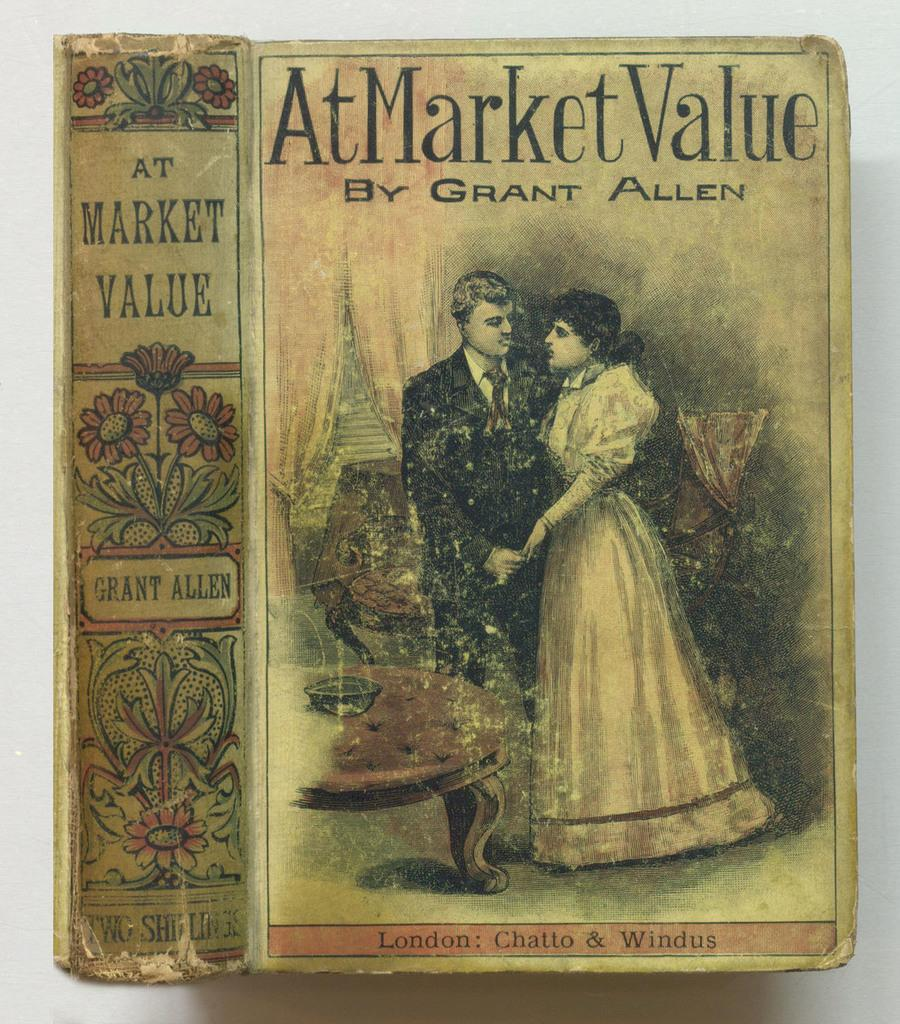<image>
Present a compact description of the photo's key features. An antique book titled At Market Value by Grant Allen features a man and woman on the cover 